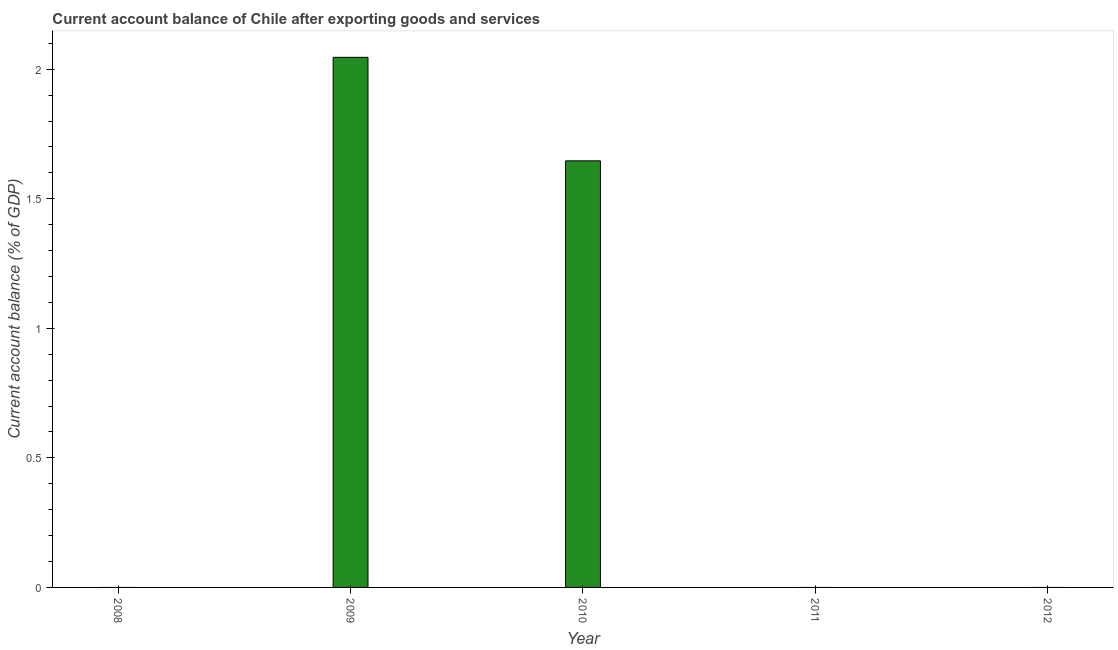Does the graph contain any zero values?
Keep it short and to the point. Yes. What is the title of the graph?
Provide a short and direct response. Current account balance of Chile after exporting goods and services. What is the label or title of the Y-axis?
Your response must be concise. Current account balance (% of GDP). Across all years, what is the maximum current account balance?
Your answer should be very brief. 2.05. Across all years, what is the minimum current account balance?
Keep it short and to the point. 0. What is the sum of the current account balance?
Provide a short and direct response. 3.69. What is the difference between the current account balance in 2009 and 2010?
Your answer should be compact. 0.4. What is the average current account balance per year?
Offer a terse response. 0.74. In how many years, is the current account balance greater than 0.5 %?
Offer a terse response. 2. What is the difference between the highest and the lowest current account balance?
Keep it short and to the point. 2.05. How many bars are there?
Make the answer very short. 2. Are all the bars in the graph horizontal?
Your answer should be compact. No. What is the difference between two consecutive major ticks on the Y-axis?
Provide a short and direct response. 0.5. Are the values on the major ticks of Y-axis written in scientific E-notation?
Your answer should be compact. No. What is the Current account balance (% of GDP) of 2009?
Your response must be concise. 2.05. What is the Current account balance (% of GDP) in 2010?
Your answer should be compact. 1.65. What is the difference between the Current account balance (% of GDP) in 2009 and 2010?
Give a very brief answer. 0.4. What is the ratio of the Current account balance (% of GDP) in 2009 to that in 2010?
Your response must be concise. 1.24. 